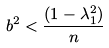<formula> <loc_0><loc_0><loc_500><loc_500>b ^ { 2 } < \frac { ( 1 - \lambda _ { 1 } ^ { 2 } ) } { n }</formula> 